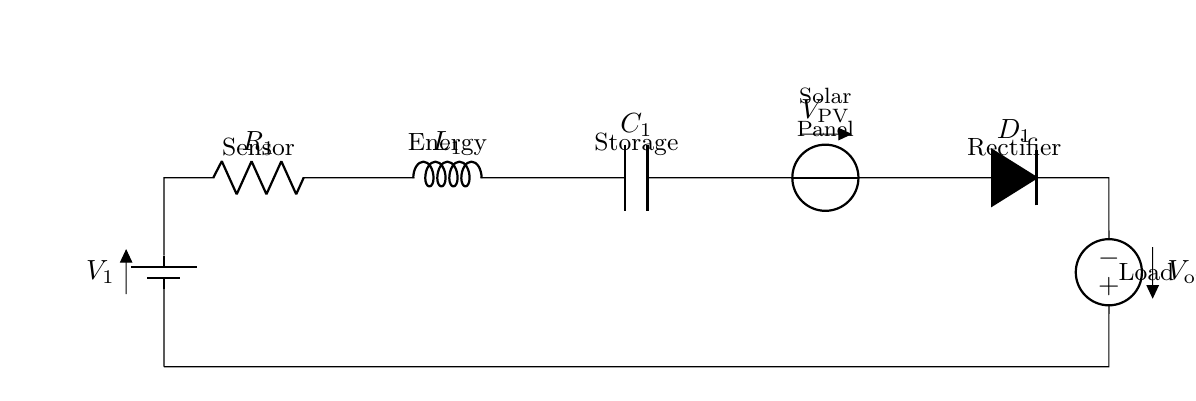What is the type of the circuit? This is a series circuit because all the components are connected in a single path for the current to flow. There is no branching, meaning the same current flows through each component of the circuit.
Answer: Series How many components are in the circuit? There are six components in the circuit: one battery, one resistor, one inductor, one capacitor, one voltage source for solar energy, and one rectifier. Each element serves a specific function in the energy harvesting process.
Answer: Six What is the role of the solar panel? The solar panel acts as a voltage source that supplies energy harvested from sunlight. It converts solar energy into electrical energy, which is then used to power the sensor network.
Answer: Voltage source What is the purpose of the rectifier? The rectifier's purpose is to convert alternating current from the solar panel into direct current, making the power suitable for charging the load and ensuring compatibility with the sensor network's requirements.
Answer: Convert AC to DC What happens when the capacitor is fully charged? When the capacitor is fully charged, it stores energy, which can then be released to power the load when needed. This ensures that the sensor network operates smoothly, even in low light conditions or during periods without solar energy.
Answer: Stores energy What is the expected output voltage for the load? The output voltage for the load is determined by the voltage drop across the components in series and the input characteristics of the solar panel. Typically, it should match the operating voltage of the sensor network for optimal performance.
Answer: V out 